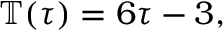Convert formula to latex. <formula><loc_0><loc_0><loc_500><loc_500>\begin{array} { r } { \mathbb { T } ( \tau ) = 6 \tau - 3 , } \end{array}</formula> 